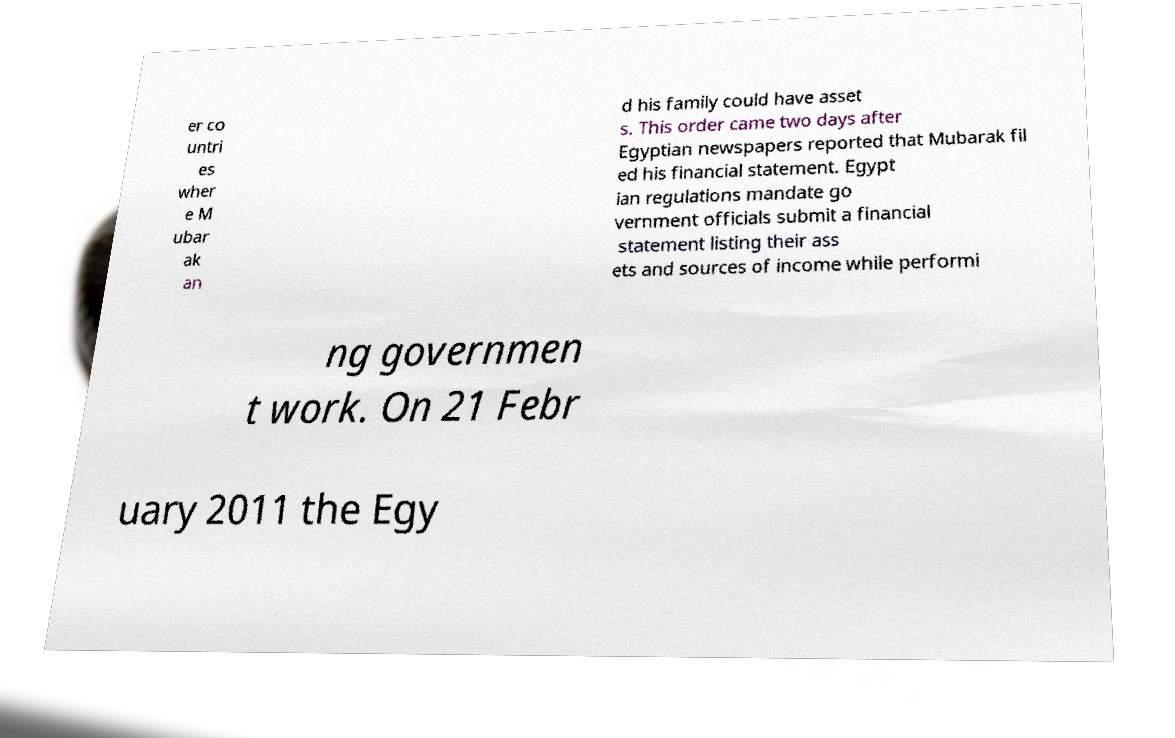There's text embedded in this image that I need extracted. Can you transcribe it verbatim? er co untri es wher e M ubar ak an d his family could have asset s. This order came two days after Egyptian newspapers reported that Mubarak fil ed his financial statement. Egypt ian regulations mandate go vernment officials submit a financial statement listing their ass ets and sources of income while performi ng governmen t work. On 21 Febr uary 2011 the Egy 